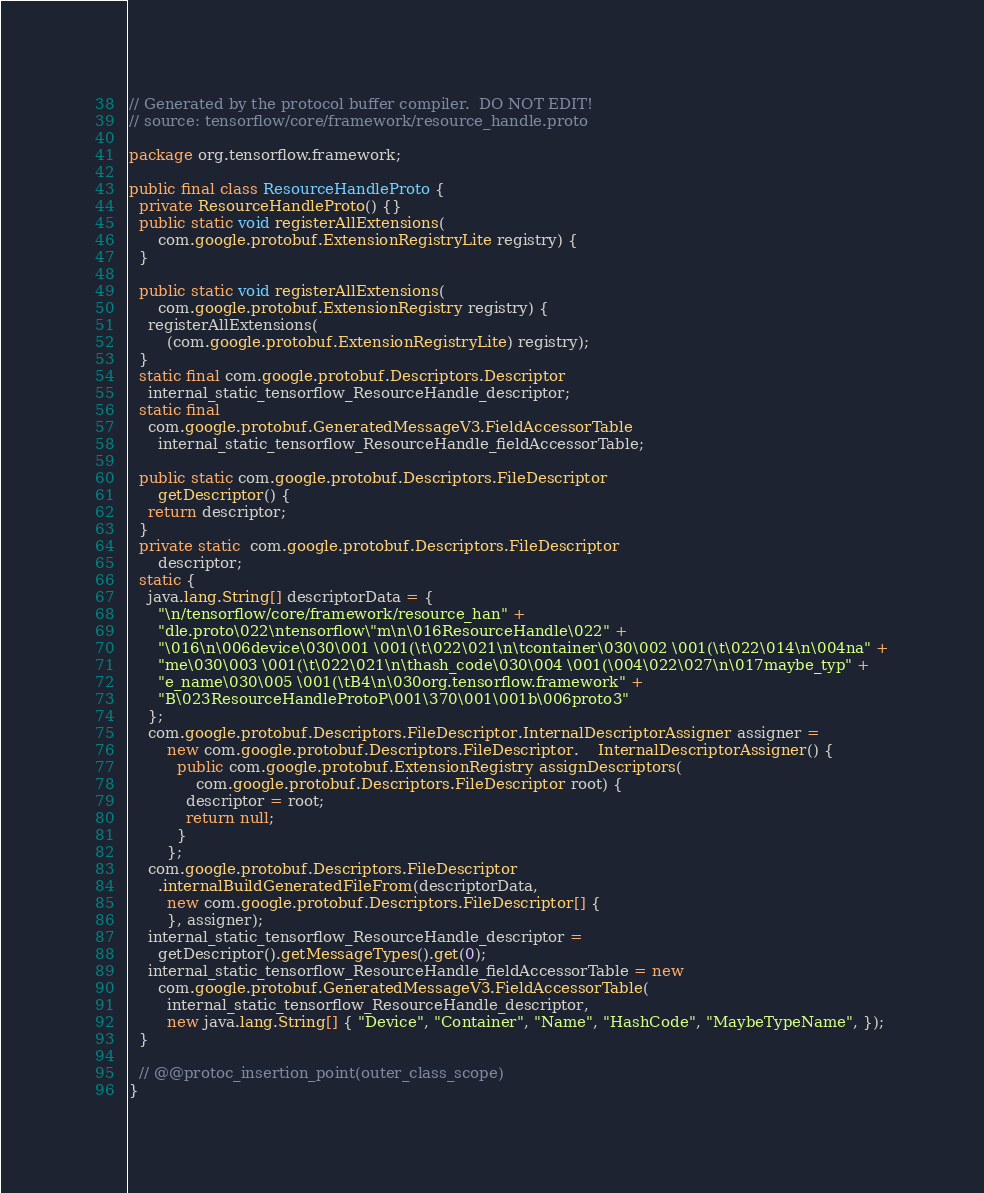Convert code to text. <code><loc_0><loc_0><loc_500><loc_500><_Java_>// Generated by the protocol buffer compiler.  DO NOT EDIT!
// source: tensorflow/core/framework/resource_handle.proto

package org.tensorflow.framework;

public final class ResourceHandleProto {
  private ResourceHandleProto() {}
  public static void registerAllExtensions(
      com.google.protobuf.ExtensionRegistryLite registry) {
  }

  public static void registerAllExtensions(
      com.google.protobuf.ExtensionRegistry registry) {
    registerAllExtensions(
        (com.google.protobuf.ExtensionRegistryLite) registry);
  }
  static final com.google.protobuf.Descriptors.Descriptor
    internal_static_tensorflow_ResourceHandle_descriptor;
  static final 
    com.google.protobuf.GeneratedMessageV3.FieldAccessorTable
      internal_static_tensorflow_ResourceHandle_fieldAccessorTable;

  public static com.google.protobuf.Descriptors.FileDescriptor
      getDescriptor() {
    return descriptor;
  }
  private static  com.google.protobuf.Descriptors.FileDescriptor
      descriptor;
  static {
    java.lang.String[] descriptorData = {
      "\n/tensorflow/core/framework/resource_han" +
      "dle.proto\022\ntensorflow\"m\n\016ResourceHandle\022" +
      "\016\n\006device\030\001 \001(\t\022\021\n\tcontainer\030\002 \001(\t\022\014\n\004na" +
      "me\030\003 \001(\t\022\021\n\thash_code\030\004 \001(\004\022\027\n\017maybe_typ" +
      "e_name\030\005 \001(\tB4\n\030org.tensorflow.framework" +
      "B\023ResourceHandleProtoP\001\370\001\001b\006proto3"
    };
    com.google.protobuf.Descriptors.FileDescriptor.InternalDescriptorAssigner assigner =
        new com.google.protobuf.Descriptors.FileDescriptor.    InternalDescriptorAssigner() {
          public com.google.protobuf.ExtensionRegistry assignDescriptors(
              com.google.protobuf.Descriptors.FileDescriptor root) {
            descriptor = root;
            return null;
          }
        };
    com.google.protobuf.Descriptors.FileDescriptor
      .internalBuildGeneratedFileFrom(descriptorData,
        new com.google.protobuf.Descriptors.FileDescriptor[] {
        }, assigner);
    internal_static_tensorflow_ResourceHandle_descriptor =
      getDescriptor().getMessageTypes().get(0);
    internal_static_tensorflow_ResourceHandle_fieldAccessorTable = new
      com.google.protobuf.GeneratedMessageV3.FieldAccessorTable(
        internal_static_tensorflow_ResourceHandle_descriptor,
        new java.lang.String[] { "Device", "Container", "Name", "HashCode", "MaybeTypeName", });
  }

  // @@protoc_insertion_point(outer_class_scope)
}
</code> 